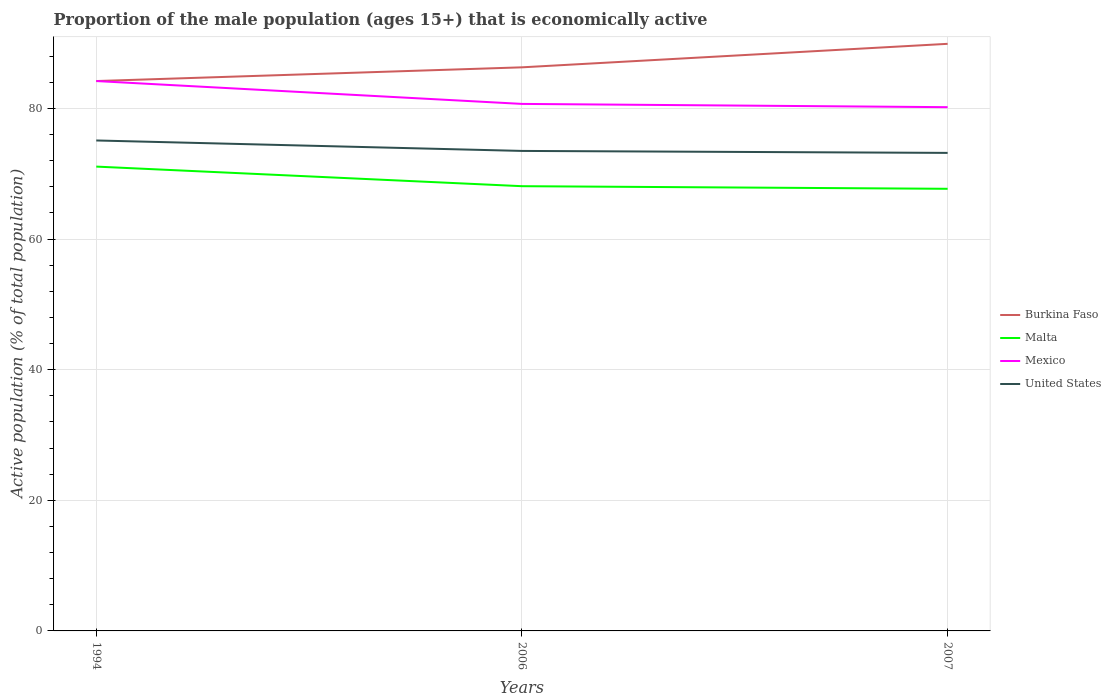Does the line corresponding to Malta intersect with the line corresponding to Burkina Faso?
Give a very brief answer. No. Across all years, what is the maximum proportion of the male population that is economically active in Malta?
Provide a succinct answer. 67.7. In which year was the proportion of the male population that is economically active in Malta maximum?
Give a very brief answer. 2007. What is the total proportion of the male population that is economically active in Burkina Faso in the graph?
Your response must be concise. -5.7. What is the difference between the highest and the second highest proportion of the male population that is economically active in Mexico?
Your answer should be compact. 4. What is the difference between the highest and the lowest proportion of the male population that is economically active in Burkina Faso?
Give a very brief answer. 1. Is the proportion of the male population that is economically active in Malta strictly greater than the proportion of the male population that is economically active in United States over the years?
Your response must be concise. Yes. What is the difference between two consecutive major ticks on the Y-axis?
Provide a short and direct response. 20. Are the values on the major ticks of Y-axis written in scientific E-notation?
Give a very brief answer. No. Does the graph contain any zero values?
Make the answer very short. No. How many legend labels are there?
Provide a short and direct response. 4. How are the legend labels stacked?
Provide a short and direct response. Vertical. What is the title of the graph?
Your answer should be very brief. Proportion of the male population (ages 15+) that is economically active. Does "Singapore" appear as one of the legend labels in the graph?
Provide a succinct answer. No. What is the label or title of the X-axis?
Make the answer very short. Years. What is the label or title of the Y-axis?
Give a very brief answer. Active population (% of total population). What is the Active population (% of total population) in Burkina Faso in 1994?
Your response must be concise. 84.2. What is the Active population (% of total population) in Malta in 1994?
Keep it short and to the point. 71.1. What is the Active population (% of total population) in Mexico in 1994?
Provide a short and direct response. 84.2. What is the Active population (% of total population) in United States in 1994?
Ensure brevity in your answer.  75.1. What is the Active population (% of total population) in Burkina Faso in 2006?
Your response must be concise. 86.3. What is the Active population (% of total population) of Malta in 2006?
Ensure brevity in your answer.  68.1. What is the Active population (% of total population) of Mexico in 2006?
Your answer should be compact. 80.7. What is the Active population (% of total population) in United States in 2006?
Your answer should be very brief. 73.5. What is the Active population (% of total population) in Burkina Faso in 2007?
Offer a very short reply. 89.9. What is the Active population (% of total population) in Malta in 2007?
Offer a terse response. 67.7. What is the Active population (% of total population) of Mexico in 2007?
Keep it short and to the point. 80.2. What is the Active population (% of total population) of United States in 2007?
Ensure brevity in your answer.  73.2. Across all years, what is the maximum Active population (% of total population) of Burkina Faso?
Ensure brevity in your answer.  89.9. Across all years, what is the maximum Active population (% of total population) in Malta?
Ensure brevity in your answer.  71.1. Across all years, what is the maximum Active population (% of total population) in Mexico?
Provide a short and direct response. 84.2. Across all years, what is the maximum Active population (% of total population) of United States?
Your answer should be very brief. 75.1. Across all years, what is the minimum Active population (% of total population) of Burkina Faso?
Your answer should be compact. 84.2. Across all years, what is the minimum Active population (% of total population) of Malta?
Your answer should be compact. 67.7. Across all years, what is the minimum Active population (% of total population) in Mexico?
Offer a very short reply. 80.2. Across all years, what is the minimum Active population (% of total population) of United States?
Make the answer very short. 73.2. What is the total Active population (% of total population) of Burkina Faso in the graph?
Offer a terse response. 260.4. What is the total Active population (% of total population) of Malta in the graph?
Your response must be concise. 206.9. What is the total Active population (% of total population) of Mexico in the graph?
Make the answer very short. 245.1. What is the total Active population (% of total population) in United States in the graph?
Provide a succinct answer. 221.8. What is the difference between the Active population (% of total population) of Mexico in 1994 and that in 2006?
Offer a terse response. 3.5. What is the difference between the Active population (% of total population) of Malta in 1994 and that in 2007?
Your answer should be very brief. 3.4. What is the difference between the Active population (% of total population) in Mexico in 1994 and that in 2007?
Give a very brief answer. 4. What is the difference between the Active population (% of total population) of Burkina Faso in 2006 and that in 2007?
Ensure brevity in your answer.  -3.6. What is the difference between the Active population (% of total population) in Mexico in 2006 and that in 2007?
Your answer should be very brief. 0.5. What is the difference between the Active population (% of total population) in United States in 2006 and that in 2007?
Make the answer very short. 0.3. What is the difference between the Active population (% of total population) of Burkina Faso in 1994 and the Active population (% of total population) of Mexico in 2006?
Give a very brief answer. 3.5. What is the difference between the Active population (% of total population) of Burkina Faso in 1994 and the Active population (% of total population) of United States in 2006?
Offer a very short reply. 10.7. What is the difference between the Active population (% of total population) in Malta in 1994 and the Active population (% of total population) in Mexico in 2006?
Provide a succinct answer. -9.6. What is the difference between the Active population (% of total population) of Malta in 1994 and the Active population (% of total population) of United States in 2006?
Your answer should be very brief. -2.4. What is the difference between the Active population (% of total population) in Mexico in 1994 and the Active population (% of total population) in United States in 2006?
Offer a terse response. 10.7. What is the difference between the Active population (% of total population) in Burkina Faso in 1994 and the Active population (% of total population) in Malta in 2007?
Offer a very short reply. 16.5. What is the difference between the Active population (% of total population) of Burkina Faso in 1994 and the Active population (% of total population) of United States in 2007?
Keep it short and to the point. 11. What is the difference between the Active population (% of total population) in Mexico in 1994 and the Active population (% of total population) in United States in 2007?
Ensure brevity in your answer.  11. What is the difference between the Active population (% of total population) of Burkina Faso in 2006 and the Active population (% of total population) of Malta in 2007?
Ensure brevity in your answer.  18.6. What is the difference between the Active population (% of total population) in Burkina Faso in 2006 and the Active population (% of total population) in United States in 2007?
Your answer should be very brief. 13.1. What is the average Active population (% of total population) in Burkina Faso per year?
Your response must be concise. 86.8. What is the average Active population (% of total population) of Malta per year?
Provide a short and direct response. 68.97. What is the average Active population (% of total population) of Mexico per year?
Your answer should be very brief. 81.7. What is the average Active population (% of total population) in United States per year?
Give a very brief answer. 73.93. In the year 1994, what is the difference between the Active population (% of total population) in Burkina Faso and Active population (% of total population) in United States?
Your response must be concise. 9.1. In the year 1994, what is the difference between the Active population (% of total population) of Malta and Active population (% of total population) of United States?
Your response must be concise. -4. In the year 1994, what is the difference between the Active population (% of total population) of Mexico and Active population (% of total population) of United States?
Your answer should be very brief. 9.1. In the year 2006, what is the difference between the Active population (% of total population) in Burkina Faso and Active population (% of total population) in Malta?
Your answer should be very brief. 18.2. In the year 2006, what is the difference between the Active population (% of total population) of Burkina Faso and Active population (% of total population) of United States?
Offer a terse response. 12.8. In the year 2006, what is the difference between the Active population (% of total population) in Mexico and Active population (% of total population) in United States?
Offer a very short reply. 7.2. In the year 2007, what is the difference between the Active population (% of total population) of Burkina Faso and Active population (% of total population) of Malta?
Offer a terse response. 22.2. In the year 2007, what is the difference between the Active population (% of total population) in Burkina Faso and Active population (% of total population) in United States?
Provide a succinct answer. 16.7. In the year 2007, what is the difference between the Active population (% of total population) of Malta and Active population (% of total population) of Mexico?
Offer a terse response. -12.5. In the year 2007, what is the difference between the Active population (% of total population) of Malta and Active population (% of total population) of United States?
Your response must be concise. -5.5. In the year 2007, what is the difference between the Active population (% of total population) in Mexico and Active population (% of total population) in United States?
Keep it short and to the point. 7. What is the ratio of the Active population (% of total population) in Burkina Faso in 1994 to that in 2006?
Your answer should be very brief. 0.98. What is the ratio of the Active population (% of total population) in Malta in 1994 to that in 2006?
Provide a short and direct response. 1.04. What is the ratio of the Active population (% of total population) in Mexico in 1994 to that in 2006?
Keep it short and to the point. 1.04. What is the ratio of the Active population (% of total population) in United States in 1994 to that in 2006?
Your answer should be very brief. 1.02. What is the ratio of the Active population (% of total population) in Burkina Faso in 1994 to that in 2007?
Offer a very short reply. 0.94. What is the ratio of the Active population (% of total population) in Malta in 1994 to that in 2007?
Give a very brief answer. 1.05. What is the ratio of the Active population (% of total population) in Mexico in 1994 to that in 2007?
Your answer should be very brief. 1.05. What is the ratio of the Active population (% of total population) in United States in 1994 to that in 2007?
Ensure brevity in your answer.  1.03. What is the ratio of the Active population (% of total population) in Burkina Faso in 2006 to that in 2007?
Offer a terse response. 0.96. What is the ratio of the Active population (% of total population) of Malta in 2006 to that in 2007?
Offer a very short reply. 1.01. What is the ratio of the Active population (% of total population) in Mexico in 2006 to that in 2007?
Ensure brevity in your answer.  1.01. What is the difference between the highest and the second highest Active population (% of total population) in Burkina Faso?
Give a very brief answer. 3.6. What is the difference between the highest and the second highest Active population (% of total population) of Mexico?
Make the answer very short. 3.5. What is the difference between the highest and the lowest Active population (% of total population) in United States?
Your answer should be very brief. 1.9. 